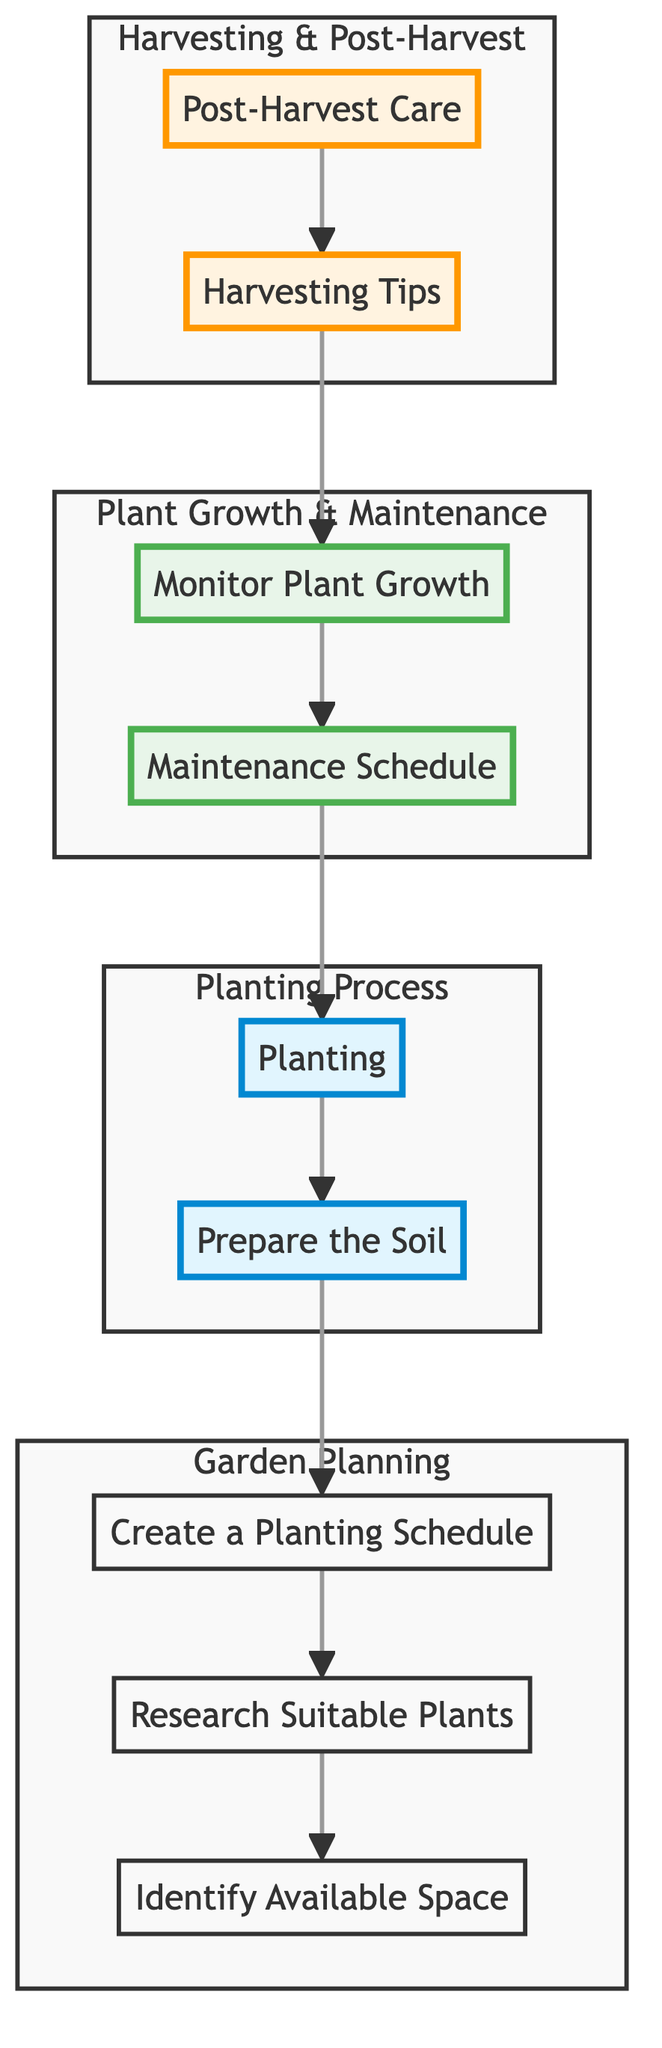What is the first step in managing a family garden? The diagram indicates that the first step is to "Identify Available Space" which is essential for assessing the garden area.
Answer: Identify Available Space How many main subgraphs are present in the diagram? The diagram contains four main subgraphs labeled as Harvesting, Growth, Planting, and Planning, which group related processes together.
Answer: Four What is the last activity in the process flow? The diagram shows that the last activity is "Post-Harvest Care," indicating what to do after harvesting is completed.
Answer: Post-Harvest Care Which subgraph includes "Monitor Plant Growth"? "Monitor Plant Growth" is located within the "Growth" subgraph, which is responsible for ongoing maintenance and health checks of the plants as they grow.
Answer: Growth What follows "Create a Planting Schedule" in the process? The process proceeds from "Create a Planting Schedule" to "Prepare the Soil," indicating that soil preparation should happen after scheduling the planting activities.
Answer: Prepare the Soil Which step comes after "Harvesting Tips"? According to the diagram, "Post-Harvest Care" comes after "Harvesting Tips," indicating that after learning how to harvest, proper care of the produce is necessary.
Answer: Post-Harvest Care How does "Planting" connect to "Maintenance Schedule"? "Planting" leads to "Maintenance Schedule" in the diagram, meaning that once planting is completed, establishing a maintenance routine is the next step in plant care.
Answer: Maintenance Schedule What is the relationship between "Research Suitable Plants" and "Create a Planting Schedule"? The relationship is sequential; "Research Suitable Plants" must be completed before creating a planting schedule, as selecting appropriate plants is crucial for effective scheduling.
Answer: Sequential What color represents the "Planting Process" subgraph? The "Planting Process" subgraph is represented in light blue according to the color coding in the diagram.
Answer: Light blue 